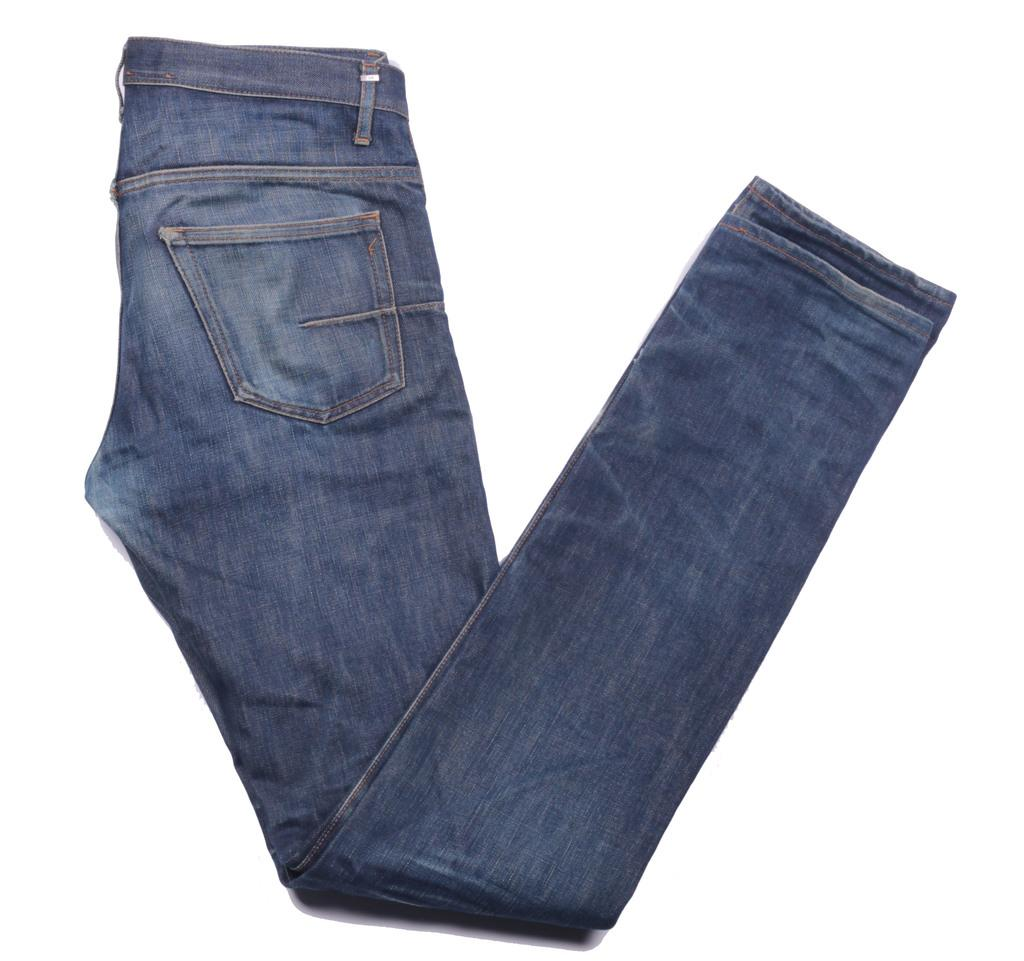What is the main subject of the image? The main subject of the image is a picture of folded jeans. How many ants can be seen crawling on the jeans in the image? There are no ants present in the image; it only features a picture of folded jeans. 